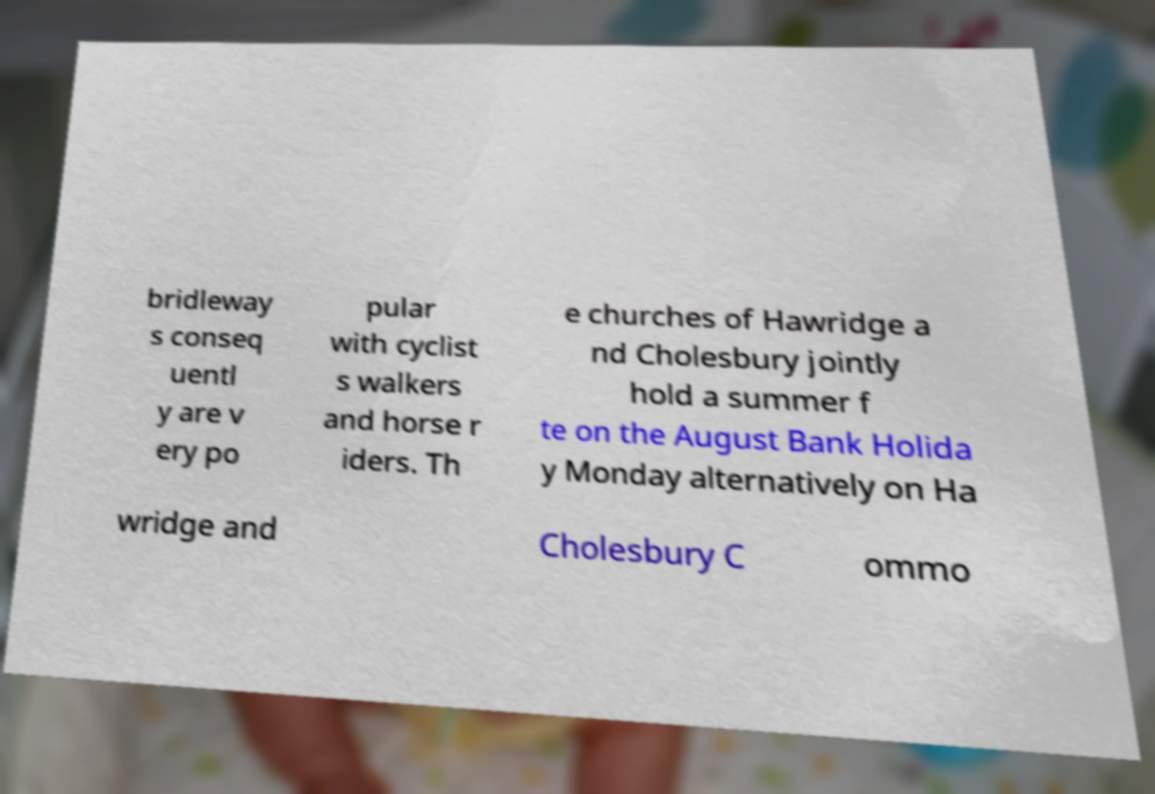Please identify and transcribe the text found in this image. bridleway s conseq uentl y are v ery po pular with cyclist s walkers and horse r iders. Th e churches of Hawridge a nd Cholesbury jointly hold a summer f te on the August Bank Holida y Monday alternatively on Ha wridge and Cholesbury C ommo 